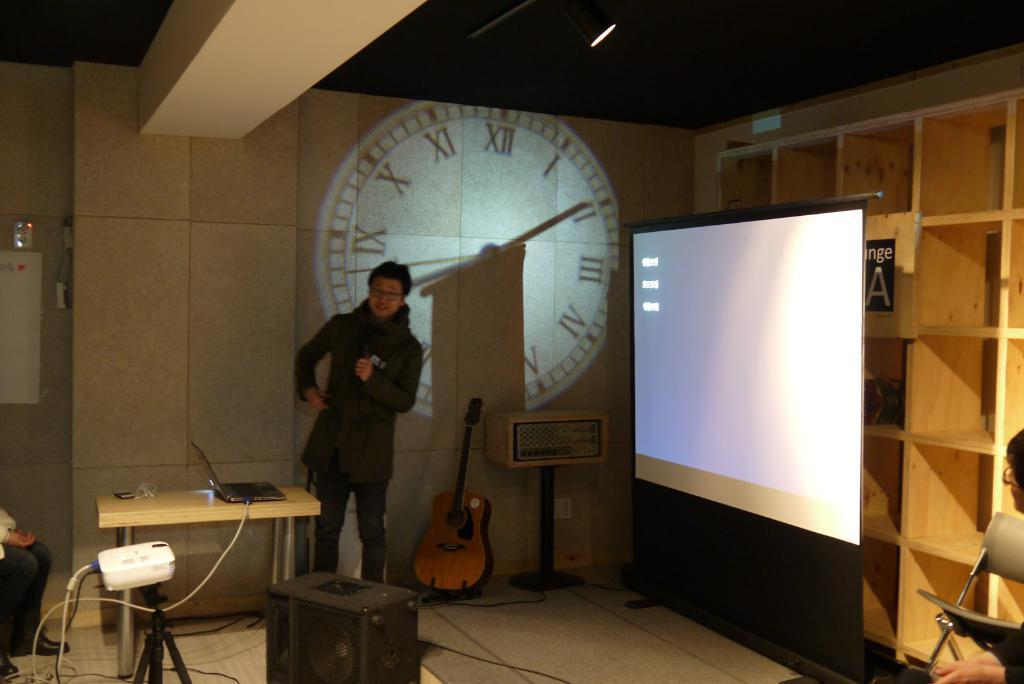What is the man in the image doing? The man is standing and presenting. How is the man projecting his content? The man is projecting from a laptop. What device is being used to display the laptop's content on a screen? A projector is being used to display the laptop's content on a screen behind the man. What musical instrument is beside the man? There is a guitar beside the man. What device is beside the man that might amplify sound? There is a speaker beside the man. What news headline is being discussed during the man's presentation? There is no news headline mentioned or visible in the image; the man is presenting from a laptop and using a projector to display content on a screen. 